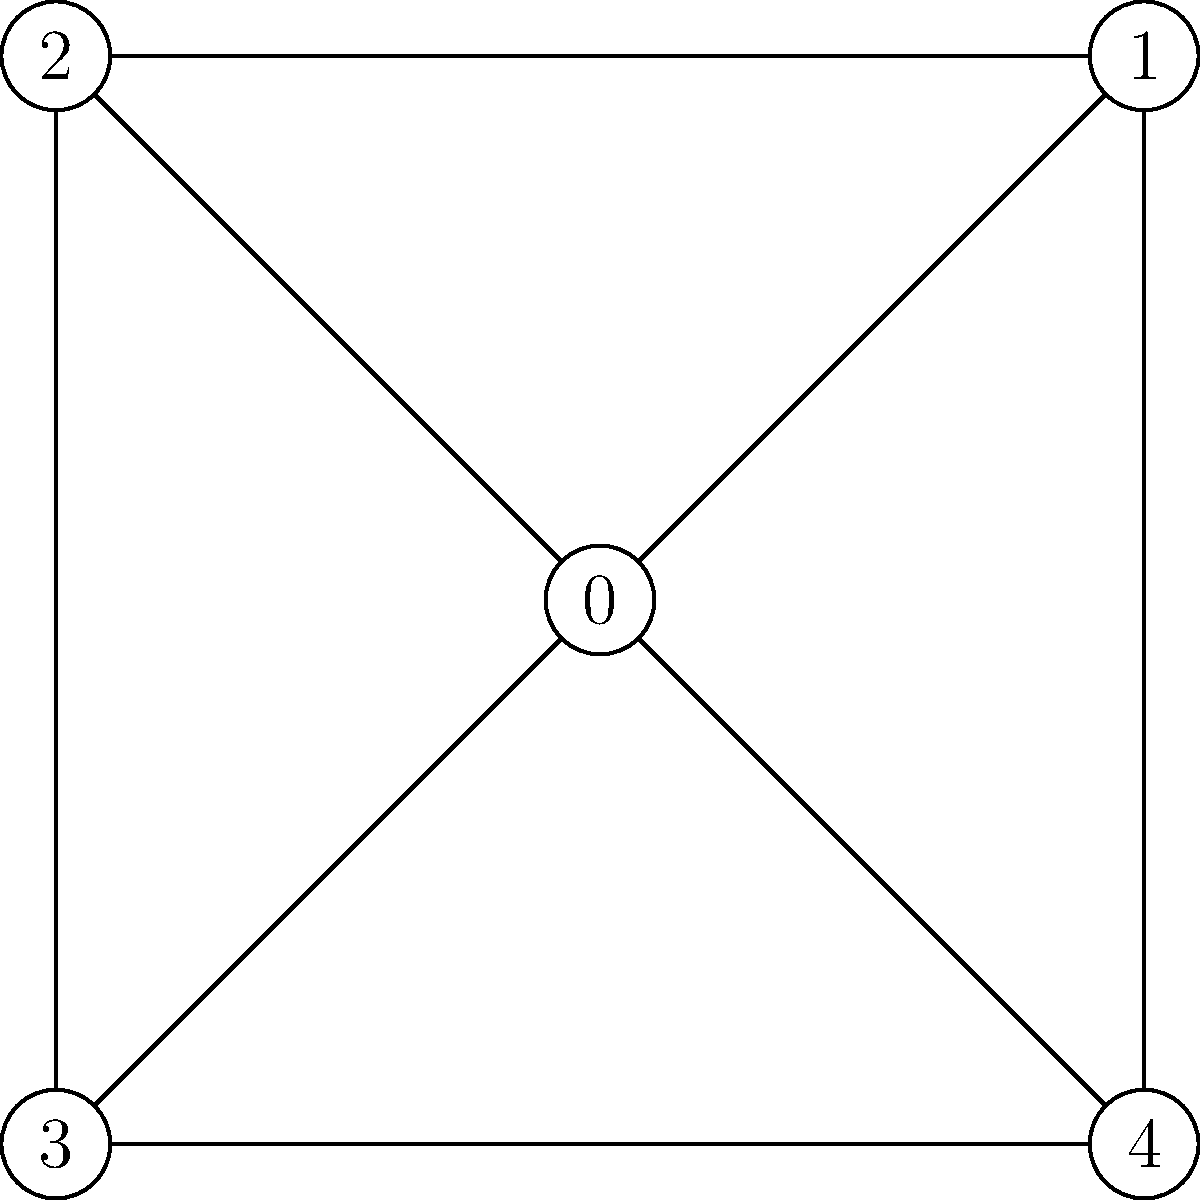In the context of moderating virtual discussion groups, consider the graph representing connections between participants in an online community. Which node has the highest degree centrality, and how might this information be useful in identifying key participants? To answer this question, we need to follow these steps:

1. Understand degree centrality:
   Degree centrality is a measure of the number of direct connections a node has in a network.

2. Count the connections for each node:
   Node 0: 4 connections
   Node 1: 3 connections
   Node 2: 3 connections
   Node 3: 3 connections
   Node 4: 3 connections

3. Identify the node with the highest degree centrality:
   Node 0 has the highest degree centrality with 4 connections.

4. Interpret the results in the context of moderating virtual discussion groups:
   - The node with the highest degree centrality (Node 0) represents a participant who is most directly connected to others in the online community.
   - This participant likely plays a central role in discussions and information sharing.
   - They may be influential in spreading information or opinions throughout the network.
   - As a moderator, identifying this key participant can be useful for:
     a) Encouraging their positive contributions to keep discussions active
     b) Monitoring their behavior to ensure they don't dominate conversations unfairly
     c) Leveraging their position to introduce new topics or redirect discussions when needed
     d) Potentially recruiting them as a co-moderator or community leader

5. Consider limitations:
   While degree centrality is useful, it's important to consider other centrality measures (e.g., betweenness, closeness) for a more comprehensive understanding of participant roles in the online community.
Answer: Node 0; highest connectivity indicates potential key participant for moderation focus. 